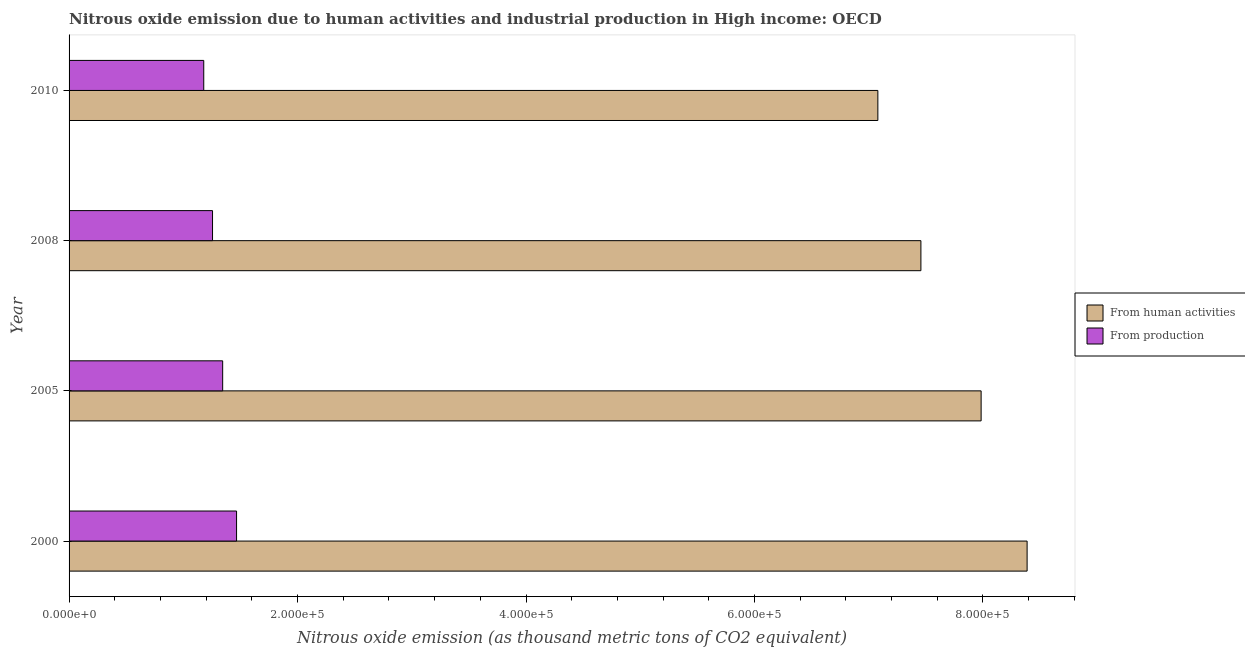How many different coloured bars are there?
Give a very brief answer. 2. Are the number of bars on each tick of the Y-axis equal?
Ensure brevity in your answer.  Yes. What is the label of the 3rd group of bars from the top?
Offer a very short reply. 2005. In how many cases, is the number of bars for a given year not equal to the number of legend labels?
Offer a terse response. 0. What is the amount of emissions from human activities in 2005?
Ensure brevity in your answer.  7.98e+05. Across all years, what is the maximum amount of emissions generated from industries?
Keep it short and to the point. 1.47e+05. Across all years, what is the minimum amount of emissions generated from industries?
Your answer should be compact. 1.18e+05. In which year was the amount of emissions generated from industries maximum?
Your answer should be very brief. 2000. In which year was the amount of emissions generated from industries minimum?
Offer a terse response. 2010. What is the total amount of emissions from human activities in the graph?
Provide a succinct answer. 3.09e+06. What is the difference between the amount of emissions from human activities in 2005 and that in 2008?
Keep it short and to the point. 5.27e+04. What is the difference between the amount of emissions from human activities in 2008 and the amount of emissions generated from industries in 2010?
Make the answer very short. 6.28e+05. What is the average amount of emissions from human activities per year?
Offer a terse response. 7.73e+05. In the year 2000, what is the difference between the amount of emissions from human activities and amount of emissions generated from industries?
Offer a very short reply. 6.92e+05. In how many years, is the amount of emissions generated from industries greater than 640000 thousand metric tons?
Give a very brief answer. 0. What is the ratio of the amount of emissions from human activities in 2005 to that in 2008?
Provide a short and direct response. 1.07. Is the difference between the amount of emissions generated from industries in 2008 and 2010 greater than the difference between the amount of emissions from human activities in 2008 and 2010?
Provide a succinct answer. No. What is the difference between the highest and the second highest amount of emissions from human activities?
Your response must be concise. 4.02e+04. What is the difference between the highest and the lowest amount of emissions generated from industries?
Your answer should be very brief. 2.87e+04. In how many years, is the amount of emissions from human activities greater than the average amount of emissions from human activities taken over all years?
Offer a terse response. 2. What does the 1st bar from the top in 2005 represents?
Your response must be concise. From production. What does the 2nd bar from the bottom in 2010 represents?
Your answer should be compact. From production. What is the difference between two consecutive major ticks on the X-axis?
Keep it short and to the point. 2.00e+05. Are the values on the major ticks of X-axis written in scientific E-notation?
Your answer should be compact. Yes. Does the graph contain any zero values?
Make the answer very short. No. Where does the legend appear in the graph?
Your answer should be very brief. Center right. How many legend labels are there?
Make the answer very short. 2. What is the title of the graph?
Offer a terse response. Nitrous oxide emission due to human activities and industrial production in High income: OECD. What is the label or title of the X-axis?
Give a very brief answer. Nitrous oxide emission (as thousand metric tons of CO2 equivalent). What is the label or title of the Y-axis?
Your response must be concise. Year. What is the Nitrous oxide emission (as thousand metric tons of CO2 equivalent) in From human activities in 2000?
Provide a short and direct response. 8.39e+05. What is the Nitrous oxide emission (as thousand metric tons of CO2 equivalent) in From production in 2000?
Offer a terse response. 1.47e+05. What is the Nitrous oxide emission (as thousand metric tons of CO2 equivalent) of From human activities in 2005?
Ensure brevity in your answer.  7.98e+05. What is the Nitrous oxide emission (as thousand metric tons of CO2 equivalent) in From production in 2005?
Your answer should be very brief. 1.34e+05. What is the Nitrous oxide emission (as thousand metric tons of CO2 equivalent) in From human activities in 2008?
Offer a terse response. 7.46e+05. What is the Nitrous oxide emission (as thousand metric tons of CO2 equivalent) in From production in 2008?
Give a very brief answer. 1.26e+05. What is the Nitrous oxide emission (as thousand metric tons of CO2 equivalent) of From human activities in 2010?
Offer a very short reply. 7.08e+05. What is the Nitrous oxide emission (as thousand metric tons of CO2 equivalent) in From production in 2010?
Make the answer very short. 1.18e+05. Across all years, what is the maximum Nitrous oxide emission (as thousand metric tons of CO2 equivalent) in From human activities?
Your answer should be very brief. 8.39e+05. Across all years, what is the maximum Nitrous oxide emission (as thousand metric tons of CO2 equivalent) of From production?
Give a very brief answer. 1.47e+05. Across all years, what is the minimum Nitrous oxide emission (as thousand metric tons of CO2 equivalent) in From human activities?
Offer a terse response. 7.08e+05. Across all years, what is the minimum Nitrous oxide emission (as thousand metric tons of CO2 equivalent) in From production?
Provide a succinct answer. 1.18e+05. What is the total Nitrous oxide emission (as thousand metric tons of CO2 equivalent) in From human activities in the graph?
Keep it short and to the point. 3.09e+06. What is the total Nitrous oxide emission (as thousand metric tons of CO2 equivalent) of From production in the graph?
Your answer should be very brief. 5.25e+05. What is the difference between the Nitrous oxide emission (as thousand metric tons of CO2 equivalent) in From human activities in 2000 and that in 2005?
Give a very brief answer. 4.02e+04. What is the difference between the Nitrous oxide emission (as thousand metric tons of CO2 equivalent) in From production in 2000 and that in 2005?
Provide a succinct answer. 1.22e+04. What is the difference between the Nitrous oxide emission (as thousand metric tons of CO2 equivalent) of From human activities in 2000 and that in 2008?
Your answer should be compact. 9.30e+04. What is the difference between the Nitrous oxide emission (as thousand metric tons of CO2 equivalent) of From production in 2000 and that in 2008?
Give a very brief answer. 2.10e+04. What is the difference between the Nitrous oxide emission (as thousand metric tons of CO2 equivalent) of From human activities in 2000 and that in 2010?
Your answer should be compact. 1.31e+05. What is the difference between the Nitrous oxide emission (as thousand metric tons of CO2 equivalent) in From production in 2000 and that in 2010?
Make the answer very short. 2.87e+04. What is the difference between the Nitrous oxide emission (as thousand metric tons of CO2 equivalent) of From human activities in 2005 and that in 2008?
Provide a succinct answer. 5.27e+04. What is the difference between the Nitrous oxide emission (as thousand metric tons of CO2 equivalent) of From production in 2005 and that in 2008?
Your answer should be compact. 8873.1. What is the difference between the Nitrous oxide emission (as thousand metric tons of CO2 equivalent) in From human activities in 2005 and that in 2010?
Provide a short and direct response. 9.04e+04. What is the difference between the Nitrous oxide emission (as thousand metric tons of CO2 equivalent) of From production in 2005 and that in 2010?
Your answer should be compact. 1.66e+04. What is the difference between the Nitrous oxide emission (as thousand metric tons of CO2 equivalent) of From human activities in 2008 and that in 2010?
Your response must be concise. 3.77e+04. What is the difference between the Nitrous oxide emission (as thousand metric tons of CO2 equivalent) of From production in 2008 and that in 2010?
Your answer should be very brief. 7694.6. What is the difference between the Nitrous oxide emission (as thousand metric tons of CO2 equivalent) in From human activities in 2000 and the Nitrous oxide emission (as thousand metric tons of CO2 equivalent) in From production in 2005?
Give a very brief answer. 7.04e+05. What is the difference between the Nitrous oxide emission (as thousand metric tons of CO2 equivalent) in From human activities in 2000 and the Nitrous oxide emission (as thousand metric tons of CO2 equivalent) in From production in 2008?
Keep it short and to the point. 7.13e+05. What is the difference between the Nitrous oxide emission (as thousand metric tons of CO2 equivalent) of From human activities in 2000 and the Nitrous oxide emission (as thousand metric tons of CO2 equivalent) of From production in 2010?
Ensure brevity in your answer.  7.21e+05. What is the difference between the Nitrous oxide emission (as thousand metric tons of CO2 equivalent) in From human activities in 2005 and the Nitrous oxide emission (as thousand metric tons of CO2 equivalent) in From production in 2008?
Your response must be concise. 6.73e+05. What is the difference between the Nitrous oxide emission (as thousand metric tons of CO2 equivalent) in From human activities in 2005 and the Nitrous oxide emission (as thousand metric tons of CO2 equivalent) in From production in 2010?
Provide a short and direct response. 6.81e+05. What is the difference between the Nitrous oxide emission (as thousand metric tons of CO2 equivalent) in From human activities in 2008 and the Nitrous oxide emission (as thousand metric tons of CO2 equivalent) in From production in 2010?
Your response must be concise. 6.28e+05. What is the average Nitrous oxide emission (as thousand metric tons of CO2 equivalent) in From human activities per year?
Offer a terse response. 7.73e+05. What is the average Nitrous oxide emission (as thousand metric tons of CO2 equivalent) in From production per year?
Make the answer very short. 1.31e+05. In the year 2000, what is the difference between the Nitrous oxide emission (as thousand metric tons of CO2 equivalent) in From human activities and Nitrous oxide emission (as thousand metric tons of CO2 equivalent) in From production?
Your response must be concise. 6.92e+05. In the year 2005, what is the difference between the Nitrous oxide emission (as thousand metric tons of CO2 equivalent) of From human activities and Nitrous oxide emission (as thousand metric tons of CO2 equivalent) of From production?
Ensure brevity in your answer.  6.64e+05. In the year 2008, what is the difference between the Nitrous oxide emission (as thousand metric tons of CO2 equivalent) of From human activities and Nitrous oxide emission (as thousand metric tons of CO2 equivalent) of From production?
Your response must be concise. 6.20e+05. In the year 2010, what is the difference between the Nitrous oxide emission (as thousand metric tons of CO2 equivalent) in From human activities and Nitrous oxide emission (as thousand metric tons of CO2 equivalent) in From production?
Offer a very short reply. 5.90e+05. What is the ratio of the Nitrous oxide emission (as thousand metric tons of CO2 equivalent) of From human activities in 2000 to that in 2005?
Your answer should be very brief. 1.05. What is the ratio of the Nitrous oxide emission (as thousand metric tons of CO2 equivalent) of From production in 2000 to that in 2005?
Ensure brevity in your answer.  1.09. What is the ratio of the Nitrous oxide emission (as thousand metric tons of CO2 equivalent) of From human activities in 2000 to that in 2008?
Provide a short and direct response. 1.12. What is the ratio of the Nitrous oxide emission (as thousand metric tons of CO2 equivalent) in From production in 2000 to that in 2008?
Your response must be concise. 1.17. What is the ratio of the Nitrous oxide emission (as thousand metric tons of CO2 equivalent) of From human activities in 2000 to that in 2010?
Give a very brief answer. 1.18. What is the ratio of the Nitrous oxide emission (as thousand metric tons of CO2 equivalent) in From production in 2000 to that in 2010?
Your answer should be compact. 1.24. What is the ratio of the Nitrous oxide emission (as thousand metric tons of CO2 equivalent) of From human activities in 2005 to that in 2008?
Provide a succinct answer. 1.07. What is the ratio of the Nitrous oxide emission (as thousand metric tons of CO2 equivalent) of From production in 2005 to that in 2008?
Provide a short and direct response. 1.07. What is the ratio of the Nitrous oxide emission (as thousand metric tons of CO2 equivalent) of From human activities in 2005 to that in 2010?
Give a very brief answer. 1.13. What is the ratio of the Nitrous oxide emission (as thousand metric tons of CO2 equivalent) in From production in 2005 to that in 2010?
Your response must be concise. 1.14. What is the ratio of the Nitrous oxide emission (as thousand metric tons of CO2 equivalent) in From human activities in 2008 to that in 2010?
Your answer should be very brief. 1.05. What is the ratio of the Nitrous oxide emission (as thousand metric tons of CO2 equivalent) in From production in 2008 to that in 2010?
Offer a very short reply. 1.07. What is the difference between the highest and the second highest Nitrous oxide emission (as thousand metric tons of CO2 equivalent) in From human activities?
Make the answer very short. 4.02e+04. What is the difference between the highest and the second highest Nitrous oxide emission (as thousand metric tons of CO2 equivalent) of From production?
Your answer should be very brief. 1.22e+04. What is the difference between the highest and the lowest Nitrous oxide emission (as thousand metric tons of CO2 equivalent) of From human activities?
Your answer should be very brief. 1.31e+05. What is the difference between the highest and the lowest Nitrous oxide emission (as thousand metric tons of CO2 equivalent) in From production?
Offer a terse response. 2.87e+04. 